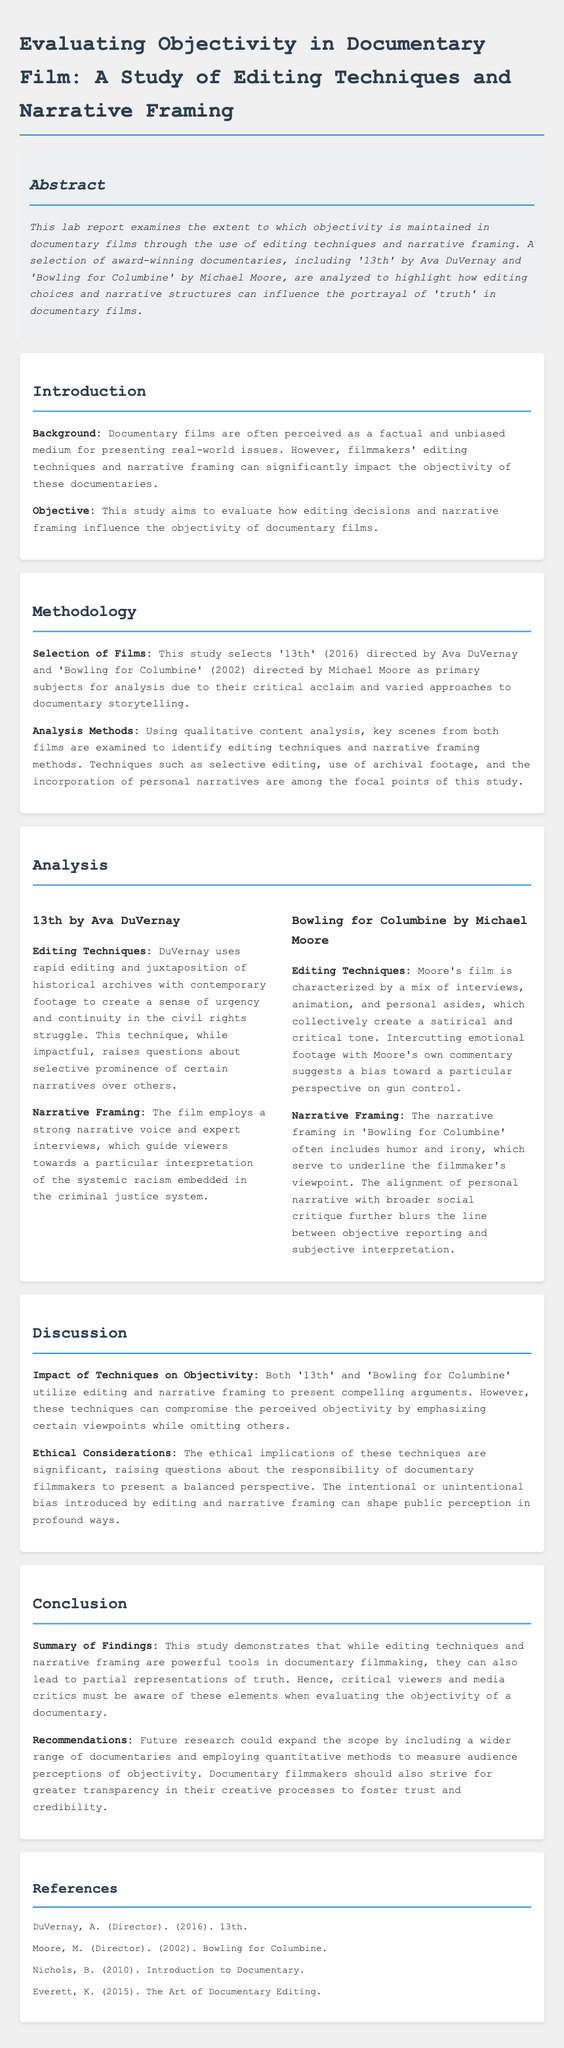What is the title of the lab report? The title of the lab report is stated in the `<title>` tag and the main heading, which is "Evaluating Objectivity in Documentary Film: A Study of Editing Techniques and Narrative Framing."
Answer: Evaluating Objectivity in Documentary Film: A Study of Editing Techniques and Narrative Framing Who directed '13th'? The director of '13th' is mentioned in the analysis section of the document.
Answer: Ava DuVernay What year was 'Bowling for Columbine' released? The release year for 'Bowling for Columbine' is specified in the selection of films within the methodology section.
Answer: 2002 Which editing technique creates a sense of urgency in '13th'? The editing technique mentioned for creating urgency in '13th' is detailed within the analysis of the film.
Answer: Rapid editing What is one of the ethical considerations discussed in the report? The ethical implications raised in the discussion section address concerns about the balance of perspectives in documentaries.
Answer: Responsibility of filmmakers What type of analysis method was used in this study? The methodology section specifies the type of analysis method that was conducted for this study.
Answer: Qualitative content analysis What is the director's name associated with the documentary 'Bowling for Columbine'? The director's name is stated as part of the film details in the references section.
Answer: Michael Moore What does the study recommend for documentary filmmakers? The recommendations specified in the conclusion suggest actions for documentary filmmakers based on the study's findings.
Answer: Strive for greater transparency 